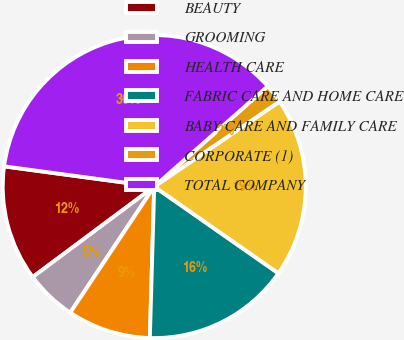Convert chart to OTSL. <chart><loc_0><loc_0><loc_500><loc_500><pie_chart><fcel>BEAUTY<fcel>GROOMING<fcel>HEALTH CARE<fcel>FABRIC CARE AND HOME CARE<fcel>BABY CARE AND FAMILY CARE<fcel>CORPORATE (1)<fcel>TOTAL COMPANY<nl><fcel>12.32%<fcel>5.46%<fcel>8.89%<fcel>15.76%<fcel>19.19%<fcel>2.03%<fcel>36.35%<nl></chart> 